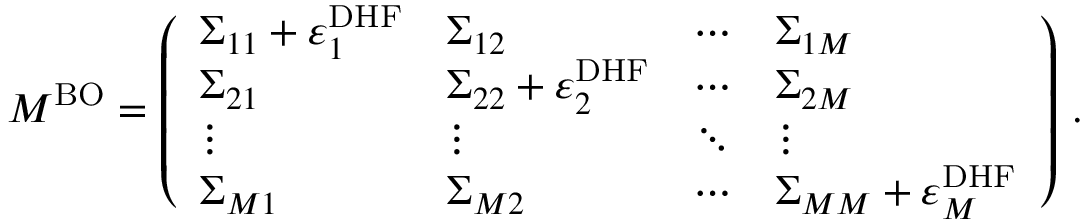<formula> <loc_0><loc_0><loc_500><loc_500>M ^ { B O } = \left ( \begin{array} { l l l l } { \Sigma _ { 1 1 } + \varepsilon _ { 1 } ^ { D H F } } & { \Sigma _ { 1 2 } } & { \cdots } & { \Sigma _ { 1 M } } \\ { \Sigma _ { 2 1 } } & { \Sigma _ { 2 2 } + \varepsilon _ { 2 } ^ { D H F } } & { \cdots } & { \Sigma _ { 2 M } } \\ { \vdots } & { \vdots } & { \ddots } & { \vdots } \\ { \Sigma _ { M 1 } } & { \Sigma _ { M 2 } } & { \cdots } & { \Sigma _ { M M } + \varepsilon _ { M } ^ { D H F } } \end{array} \right ) \, .</formula> 